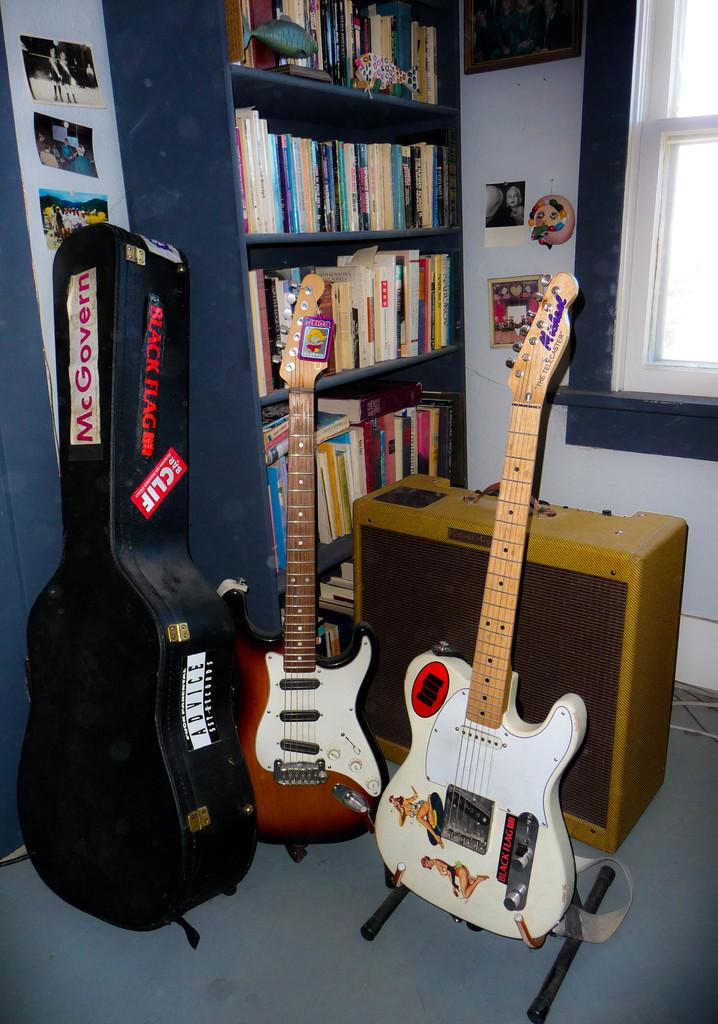How many guitars can be seen in the image? There are 2 guitars in the image. What is used to carry the guitars in the image? There is a guitar bag in the image. What else is present in the image besides guitars and the guitar bag? There are photos, a rack full of books, a window, a photo frame on the wall, and some equipment in the image. What is the price of the coach in the image? There is no coach present in the image, so it is not possible to determine its price. 